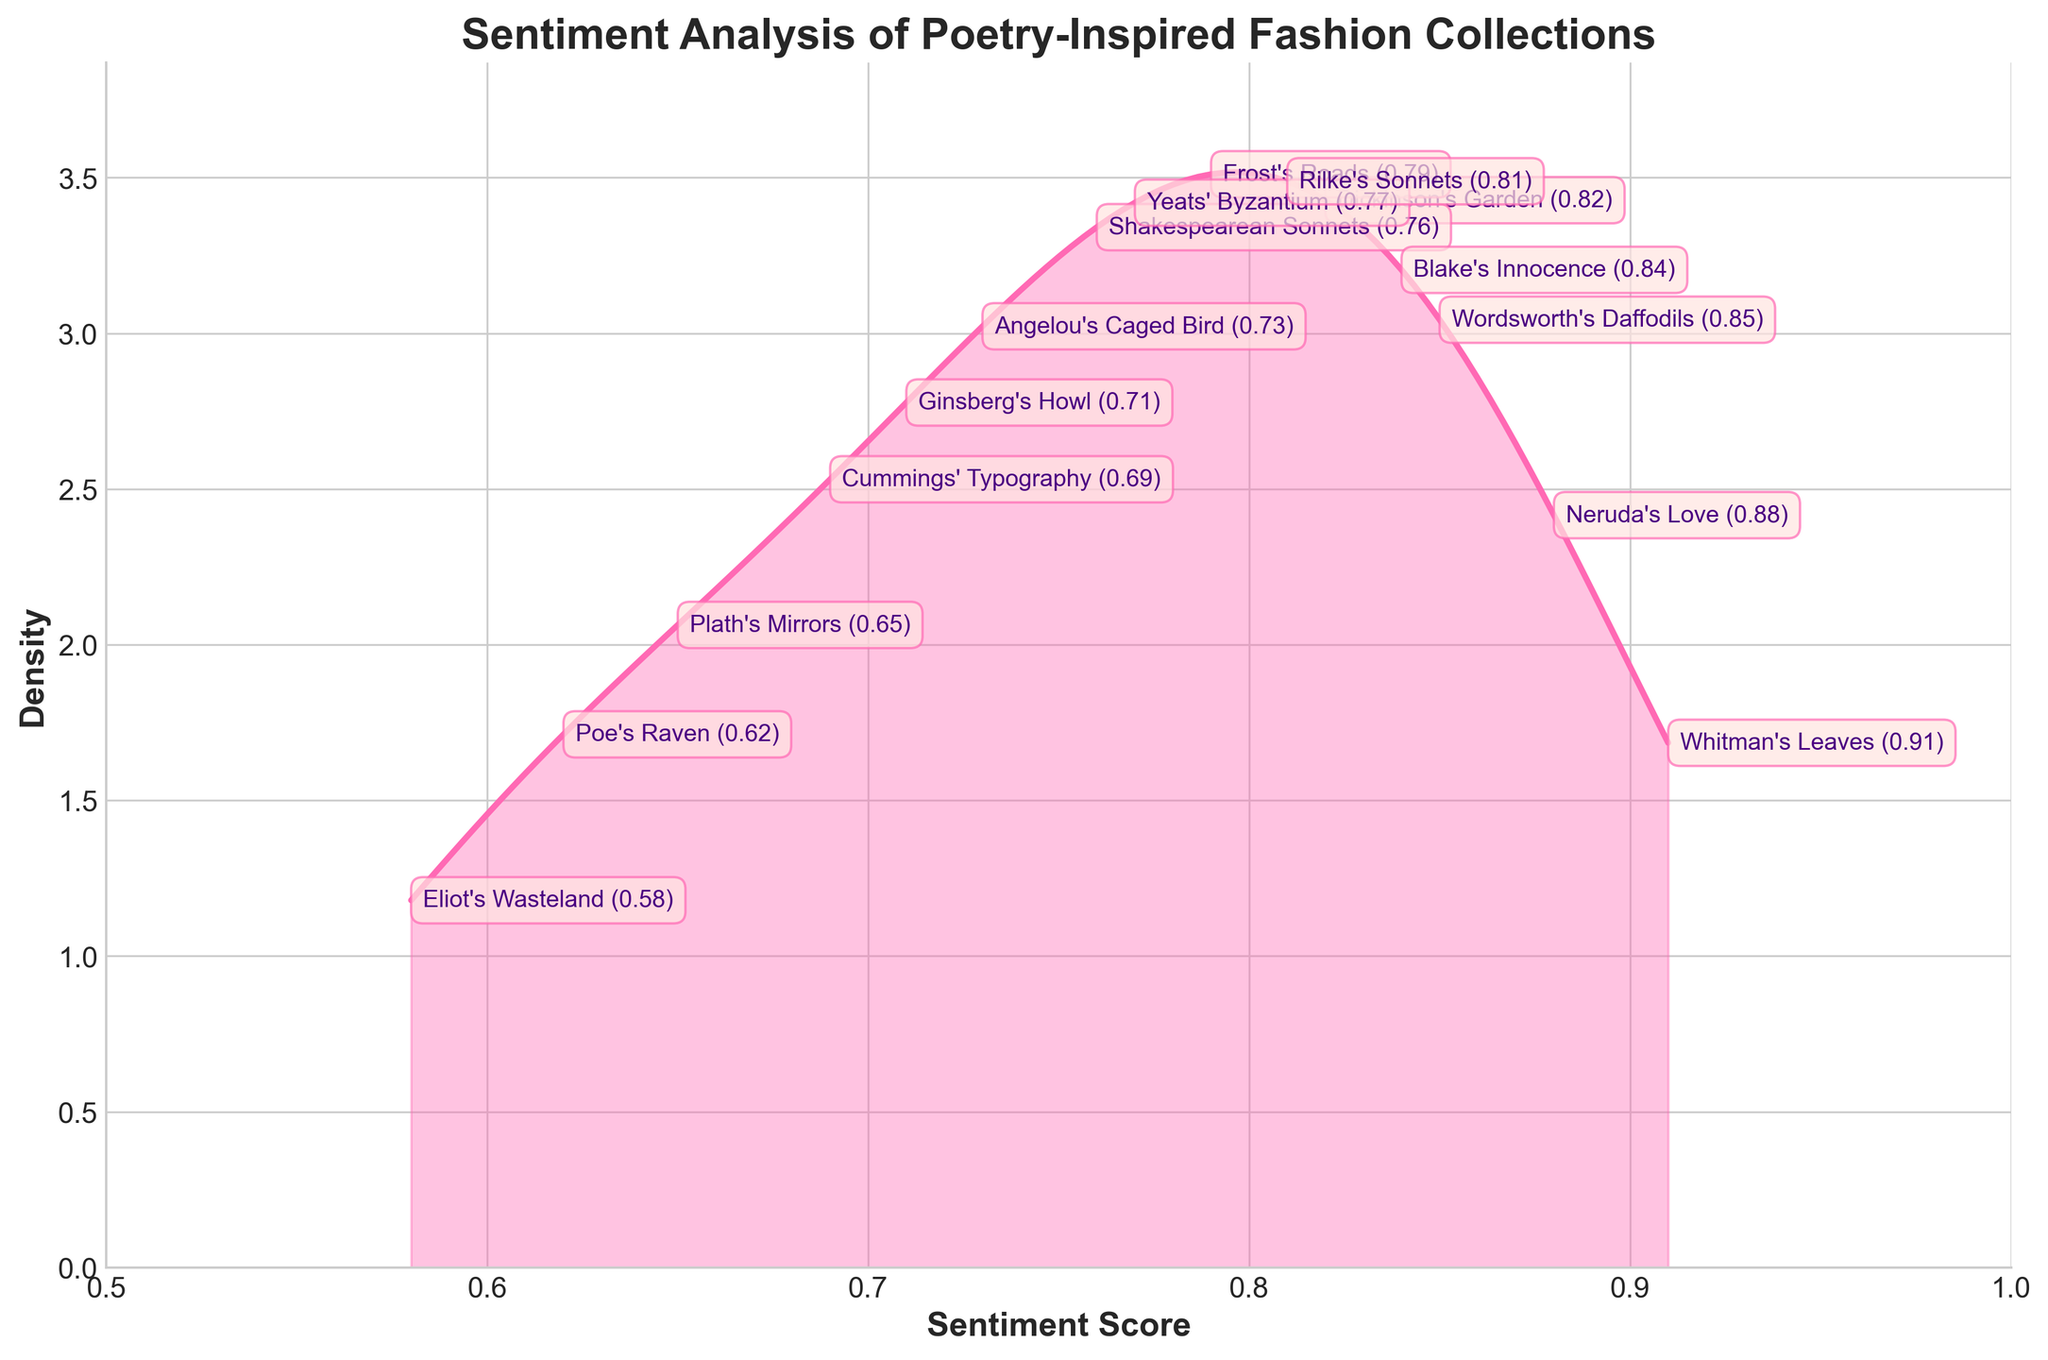What is the title of the figure? The title is usually found at the top of the figure and provides an overview of what the visual represents.
Answer: Sentiment Analysis of Poetry-Inspired Fashion Collections What is the range of sentiment scores shown on the horizontal axis? The horizontal axis, labeled 'Sentiment Score', spans from the minimum to maximum sentiment scores visible in the plot.
Answer: 0.5 to 1 Which collection has the highest sentiment score? Locate the point on the figure where the sentiment score is the highest and identify the collection associated with this score, either by annotation or data point placement.
Answer: Whitman's Leaves What is the sentiment score of 'Eliot's Wasteland'? Identify the annotation or data point corresponding to 'Eliot's Wasteland' on the density plot.
Answer: 0.58 How many collections have a sentiment score greater than 0.75? Count the number of sentiment scores annotated or plotted above the 0.75 mark on the horizontal axis.
Answer: 9 Which collections have sentiment scores lower than 0.7? Identify and list all collections whose sentiment scores fall below the 0.7 mark on the horizontal axis.
Answer: Plath's Mirrors, Eliot's Wasteland, Poe's Raven, Cummings' Typography Compare the sentiment score of 'Neruda's Love' and 'Dickinson's Garden'. Which is higher? Identify and compare the annotated sentiment scores of both 'Neruda's Love' and 'Dickinson's Garden'.
Answer: Neruda's Love (0.88) is higher than Dickinson's Garden (0.82) What is the average sentiment score of all the collections? Sum all the sentiment scores and divide by the number of collections to find the average.
Answer: (0.82+0.76+0.91+0.65+0.79+0.88+0.73+0.58+0.85+0.62+0.71+0.77+0.81+0.69+0.84) / 15 = 0.76 Which collection has the lowest sentiment score and what is it? Identify the collection with the sentiment score at the lowest point on the horizontal axis and read the corresponding value.
Answer: Eliot's Wasteland with 0.58 What is the median sentiment score? Organize the sentiment scores in ascending order and find the middle value.
Answer: 0.76 